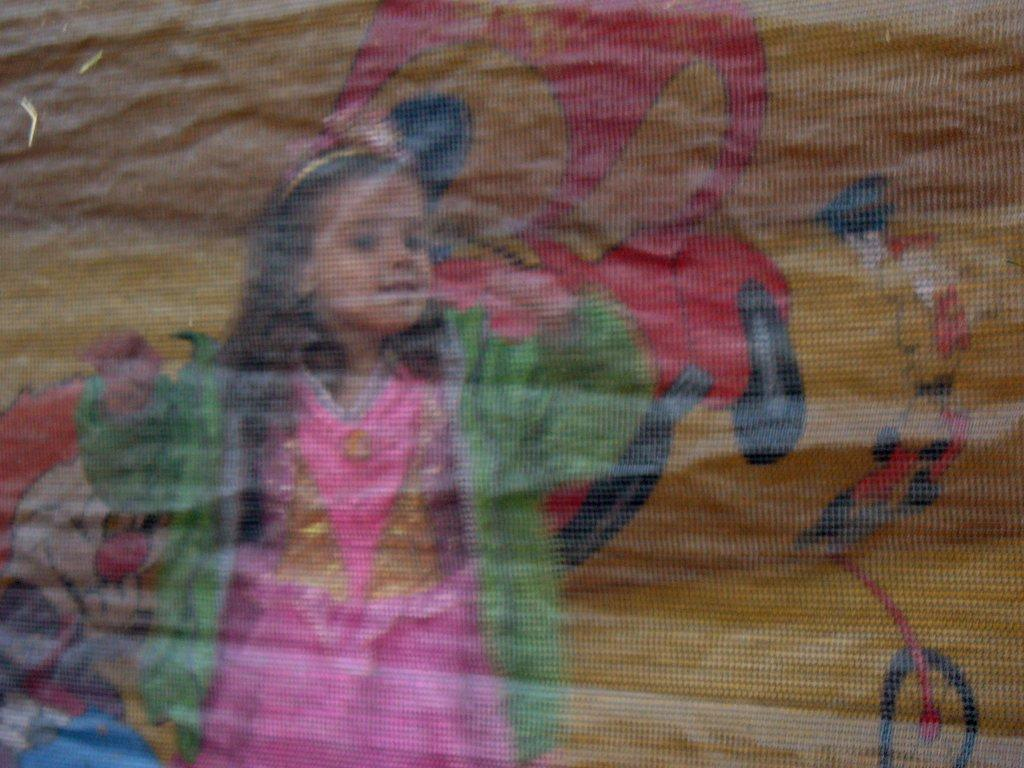Who is the main subject in the image? There is a girl in the image. What is the girl wearing? The girl is wearing a dress with pink, gold, and green colors. What can be seen in the background of the image? There is art visible in the background of the image. How far away is the robin from the girl in the image? There is no robin present in the image, so it cannot be determined how far away it would be from the girl. 